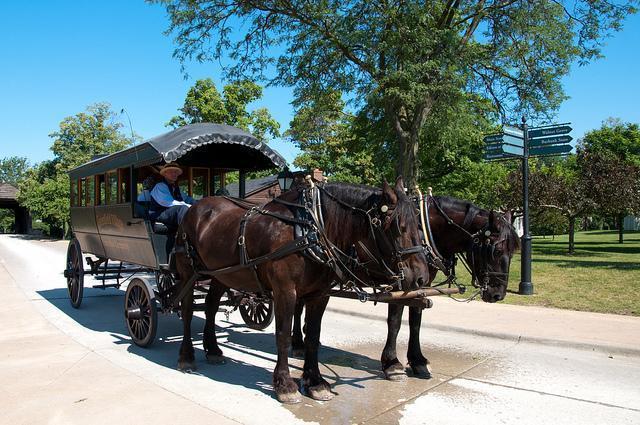What is the green item near the horses?
Choose the right answer from the provided options to respond to the question.
Options: Grape, watermelon, sign, cucumber. Sign. 